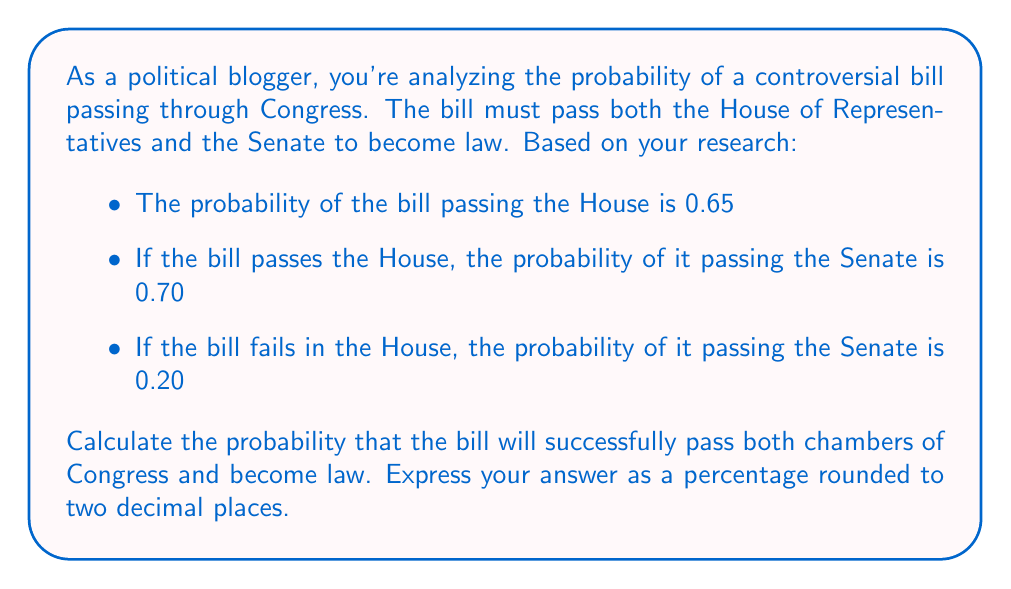Could you help me with this problem? To solve this problem, we'll use the concept of conditional probability. Let's define our events:

$H$: The bill passes the House
$S$: The bill passes the Senate

We're given the following probabilities:

$P(H) = 0.65$
$P(S|H) = 0.70$ (probability of passing Senate given it passed the House)
$P(S|\text{not }H) = 0.20$ (probability of passing Senate given it failed in the House)

We want to find $P(H \text{ and } S)$, which is the probability of the bill passing both chambers.

Using the multiplication rule of probability:

$$P(H \text{ and } S) = P(H) \cdot P(S|H)$$

Plugging in our values:

$$P(H \text{ and } S) = 0.65 \cdot 0.70 = 0.4550$$

To convert to a percentage, we multiply by 100:

$$0.4550 \cdot 100 = 45.50\%$$

Therefore, the probability of the bill passing both chambers and becoming law is 45.50%.
Answer: 45.50% 